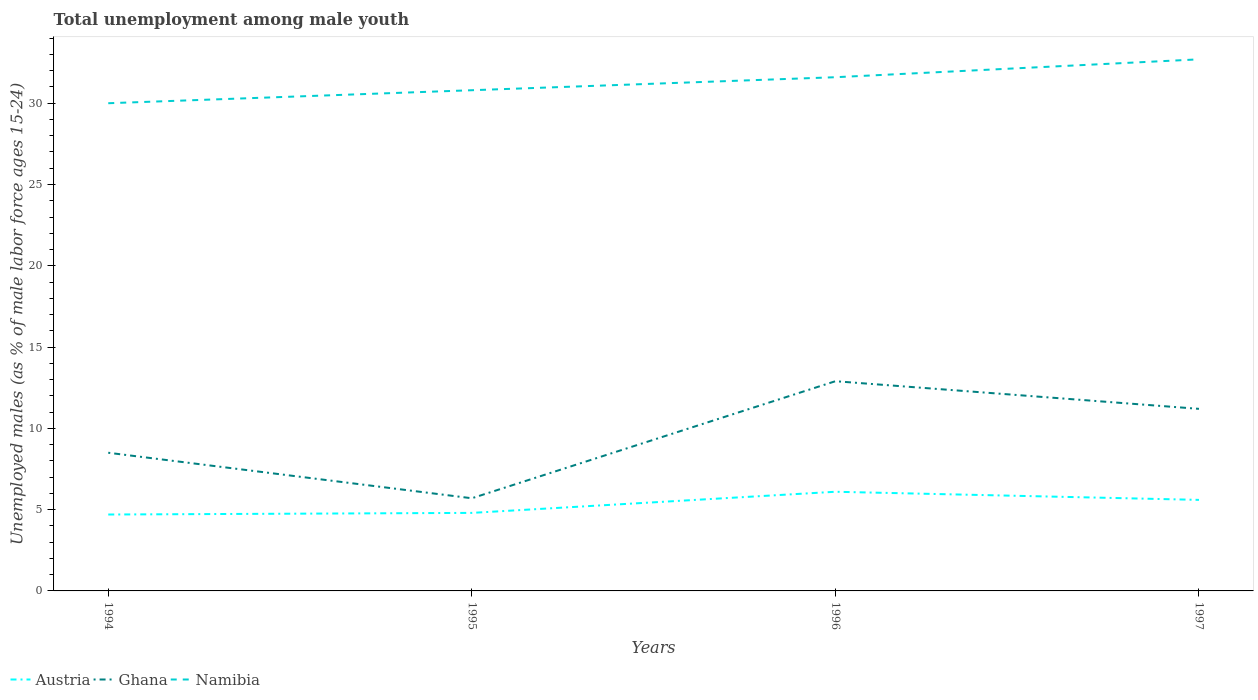Is the number of lines equal to the number of legend labels?
Ensure brevity in your answer.  Yes. Across all years, what is the maximum percentage of unemployed males in in Ghana?
Keep it short and to the point. 5.7. In which year was the percentage of unemployed males in in Ghana maximum?
Offer a terse response. 1995. What is the total percentage of unemployed males in in Ghana in the graph?
Give a very brief answer. 2.8. What is the difference between the highest and the second highest percentage of unemployed males in in Namibia?
Give a very brief answer. 2.7. Is the percentage of unemployed males in in Ghana strictly greater than the percentage of unemployed males in in Namibia over the years?
Keep it short and to the point. Yes. How many lines are there?
Your answer should be compact. 3. What is the difference between two consecutive major ticks on the Y-axis?
Ensure brevity in your answer.  5. How many legend labels are there?
Provide a succinct answer. 3. What is the title of the graph?
Your answer should be compact. Total unemployment among male youth. Does "Tanzania" appear as one of the legend labels in the graph?
Provide a succinct answer. No. What is the label or title of the X-axis?
Provide a short and direct response. Years. What is the label or title of the Y-axis?
Your response must be concise. Unemployed males (as % of male labor force ages 15-24). What is the Unemployed males (as % of male labor force ages 15-24) in Austria in 1994?
Provide a short and direct response. 4.7. What is the Unemployed males (as % of male labor force ages 15-24) in Ghana in 1994?
Provide a short and direct response. 8.5. What is the Unemployed males (as % of male labor force ages 15-24) of Namibia in 1994?
Provide a succinct answer. 30. What is the Unemployed males (as % of male labor force ages 15-24) of Austria in 1995?
Your answer should be compact. 4.8. What is the Unemployed males (as % of male labor force ages 15-24) of Ghana in 1995?
Offer a very short reply. 5.7. What is the Unemployed males (as % of male labor force ages 15-24) of Namibia in 1995?
Your answer should be very brief. 30.8. What is the Unemployed males (as % of male labor force ages 15-24) of Austria in 1996?
Your answer should be compact. 6.1. What is the Unemployed males (as % of male labor force ages 15-24) in Ghana in 1996?
Offer a terse response. 12.9. What is the Unemployed males (as % of male labor force ages 15-24) of Namibia in 1996?
Your response must be concise. 31.6. What is the Unemployed males (as % of male labor force ages 15-24) of Austria in 1997?
Offer a terse response. 5.6. What is the Unemployed males (as % of male labor force ages 15-24) in Ghana in 1997?
Provide a short and direct response. 11.2. What is the Unemployed males (as % of male labor force ages 15-24) in Namibia in 1997?
Provide a succinct answer. 32.7. Across all years, what is the maximum Unemployed males (as % of male labor force ages 15-24) in Austria?
Offer a terse response. 6.1. Across all years, what is the maximum Unemployed males (as % of male labor force ages 15-24) of Ghana?
Your answer should be very brief. 12.9. Across all years, what is the maximum Unemployed males (as % of male labor force ages 15-24) of Namibia?
Your answer should be very brief. 32.7. Across all years, what is the minimum Unemployed males (as % of male labor force ages 15-24) of Austria?
Your answer should be compact. 4.7. Across all years, what is the minimum Unemployed males (as % of male labor force ages 15-24) in Ghana?
Your answer should be compact. 5.7. Across all years, what is the minimum Unemployed males (as % of male labor force ages 15-24) of Namibia?
Give a very brief answer. 30. What is the total Unemployed males (as % of male labor force ages 15-24) in Austria in the graph?
Provide a succinct answer. 21.2. What is the total Unemployed males (as % of male labor force ages 15-24) of Ghana in the graph?
Keep it short and to the point. 38.3. What is the total Unemployed males (as % of male labor force ages 15-24) of Namibia in the graph?
Provide a short and direct response. 125.1. What is the difference between the Unemployed males (as % of male labor force ages 15-24) in Ghana in 1994 and that in 1995?
Provide a short and direct response. 2.8. What is the difference between the Unemployed males (as % of male labor force ages 15-24) of Namibia in 1994 and that in 1995?
Give a very brief answer. -0.8. What is the difference between the Unemployed males (as % of male labor force ages 15-24) in Austria in 1994 and that in 1996?
Make the answer very short. -1.4. What is the difference between the Unemployed males (as % of male labor force ages 15-24) in Ghana in 1994 and that in 1996?
Your answer should be very brief. -4.4. What is the difference between the Unemployed males (as % of male labor force ages 15-24) in Austria in 1994 and that in 1997?
Provide a short and direct response. -0.9. What is the difference between the Unemployed males (as % of male labor force ages 15-24) of Ghana in 1994 and that in 1997?
Your response must be concise. -2.7. What is the difference between the Unemployed males (as % of male labor force ages 15-24) of Namibia in 1995 and that in 1996?
Your answer should be very brief. -0.8. What is the difference between the Unemployed males (as % of male labor force ages 15-24) of Austria in 1995 and that in 1997?
Keep it short and to the point. -0.8. What is the difference between the Unemployed males (as % of male labor force ages 15-24) of Ghana in 1995 and that in 1997?
Ensure brevity in your answer.  -5.5. What is the difference between the Unemployed males (as % of male labor force ages 15-24) in Namibia in 1995 and that in 1997?
Give a very brief answer. -1.9. What is the difference between the Unemployed males (as % of male labor force ages 15-24) in Austria in 1996 and that in 1997?
Provide a succinct answer. 0.5. What is the difference between the Unemployed males (as % of male labor force ages 15-24) in Ghana in 1996 and that in 1997?
Your answer should be very brief. 1.7. What is the difference between the Unemployed males (as % of male labor force ages 15-24) in Namibia in 1996 and that in 1997?
Your answer should be compact. -1.1. What is the difference between the Unemployed males (as % of male labor force ages 15-24) in Austria in 1994 and the Unemployed males (as % of male labor force ages 15-24) in Namibia in 1995?
Provide a succinct answer. -26.1. What is the difference between the Unemployed males (as % of male labor force ages 15-24) in Ghana in 1994 and the Unemployed males (as % of male labor force ages 15-24) in Namibia in 1995?
Your answer should be very brief. -22.3. What is the difference between the Unemployed males (as % of male labor force ages 15-24) of Austria in 1994 and the Unemployed males (as % of male labor force ages 15-24) of Namibia in 1996?
Offer a very short reply. -26.9. What is the difference between the Unemployed males (as % of male labor force ages 15-24) in Ghana in 1994 and the Unemployed males (as % of male labor force ages 15-24) in Namibia in 1996?
Make the answer very short. -23.1. What is the difference between the Unemployed males (as % of male labor force ages 15-24) in Austria in 1994 and the Unemployed males (as % of male labor force ages 15-24) in Namibia in 1997?
Offer a very short reply. -28. What is the difference between the Unemployed males (as % of male labor force ages 15-24) in Ghana in 1994 and the Unemployed males (as % of male labor force ages 15-24) in Namibia in 1997?
Ensure brevity in your answer.  -24.2. What is the difference between the Unemployed males (as % of male labor force ages 15-24) of Austria in 1995 and the Unemployed males (as % of male labor force ages 15-24) of Namibia in 1996?
Offer a terse response. -26.8. What is the difference between the Unemployed males (as % of male labor force ages 15-24) of Ghana in 1995 and the Unemployed males (as % of male labor force ages 15-24) of Namibia in 1996?
Give a very brief answer. -25.9. What is the difference between the Unemployed males (as % of male labor force ages 15-24) of Austria in 1995 and the Unemployed males (as % of male labor force ages 15-24) of Ghana in 1997?
Give a very brief answer. -6.4. What is the difference between the Unemployed males (as % of male labor force ages 15-24) of Austria in 1995 and the Unemployed males (as % of male labor force ages 15-24) of Namibia in 1997?
Your response must be concise. -27.9. What is the difference between the Unemployed males (as % of male labor force ages 15-24) in Austria in 1996 and the Unemployed males (as % of male labor force ages 15-24) in Ghana in 1997?
Make the answer very short. -5.1. What is the difference between the Unemployed males (as % of male labor force ages 15-24) in Austria in 1996 and the Unemployed males (as % of male labor force ages 15-24) in Namibia in 1997?
Offer a terse response. -26.6. What is the difference between the Unemployed males (as % of male labor force ages 15-24) of Ghana in 1996 and the Unemployed males (as % of male labor force ages 15-24) of Namibia in 1997?
Your response must be concise. -19.8. What is the average Unemployed males (as % of male labor force ages 15-24) in Ghana per year?
Provide a short and direct response. 9.57. What is the average Unemployed males (as % of male labor force ages 15-24) of Namibia per year?
Keep it short and to the point. 31.27. In the year 1994, what is the difference between the Unemployed males (as % of male labor force ages 15-24) in Austria and Unemployed males (as % of male labor force ages 15-24) in Namibia?
Make the answer very short. -25.3. In the year 1994, what is the difference between the Unemployed males (as % of male labor force ages 15-24) of Ghana and Unemployed males (as % of male labor force ages 15-24) of Namibia?
Offer a terse response. -21.5. In the year 1995, what is the difference between the Unemployed males (as % of male labor force ages 15-24) of Ghana and Unemployed males (as % of male labor force ages 15-24) of Namibia?
Give a very brief answer. -25.1. In the year 1996, what is the difference between the Unemployed males (as % of male labor force ages 15-24) of Austria and Unemployed males (as % of male labor force ages 15-24) of Namibia?
Your response must be concise. -25.5. In the year 1996, what is the difference between the Unemployed males (as % of male labor force ages 15-24) of Ghana and Unemployed males (as % of male labor force ages 15-24) of Namibia?
Offer a very short reply. -18.7. In the year 1997, what is the difference between the Unemployed males (as % of male labor force ages 15-24) of Austria and Unemployed males (as % of male labor force ages 15-24) of Namibia?
Ensure brevity in your answer.  -27.1. In the year 1997, what is the difference between the Unemployed males (as % of male labor force ages 15-24) in Ghana and Unemployed males (as % of male labor force ages 15-24) in Namibia?
Offer a very short reply. -21.5. What is the ratio of the Unemployed males (as % of male labor force ages 15-24) in Austria in 1994 to that in 1995?
Ensure brevity in your answer.  0.98. What is the ratio of the Unemployed males (as % of male labor force ages 15-24) of Ghana in 1994 to that in 1995?
Your answer should be compact. 1.49. What is the ratio of the Unemployed males (as % of male labor force ages 15-24) of Namibia in 1994 to that in 1995?
Provide a short and direct response. 0.97. What is the ratio of the Unemployed males (as % of male labor force ages 15-24) of Austria in 1994 to that in 1996?
Provide a succinct answer. 0.77. What is the ratio of the Unemployed males (as % of male labor force ages 15-24) of Ghana in 1994 to that in 1996?
Provide a short and direct response. 0.66. What is the ratio of the Unemployed males (as % of male labor force ages 15-24) in Namibia in 1994 to that in 1996?
Your answer should be very brief. 0.95. What is the ratio of the Unemployed males (as % of male labor force ages 15-24) of Austria in 1994 to that in 1997?
Make the answer very short. 0.84. What is the ratio of the Unemployed males (as % of male labor force ages 15-24) of Ghana in 1994 to that in 1997?
Provide a short and direct response. 0.76. What is the ratio of the Unemployed males (as % of male labor force ages 15-24) in Namibia in 1994 to that in 1997?
Offer a very short reply. 0.92. What is the ratio of the Unemployed males (as % of male labor force ages 15-24) of Austria in 1995 to that in 1996?
Provide a succinct answer. 0.79. What is the ratio of the Unemployed males (as % of male labor force ages 15-24) of Ghana in 1995 to that in 1996?
Your answer should be compact. 0.44. What is the ratio of the Unemployed males (as % of male labor force ages 15-24) of Namibia in 1995 to that in 1996?
Provide a succinct answer. 0.97. What is the ratio of the Unemployed males (as % of male labor force ages 15-24) of Ghana in 1995 to that in 1997?
Your answer should be compact. 0.51. What is the ratio of the Unemployed males (as % of male labor force ages 15-24) of Namibia in 1995 to that in 1997?
Ensure brevity in your answer.  0.94. What is the ratio of the Unemployed males (as % of male labor force ages 15-24) in Austria in 1996 to that in 1997?
Provide a short and direct response. 1.09. What is the ratio of the Unemployed males (as % of male labor force ages 15-24) of Ghana in 1996 to that in 1997?
Make the answer very short. 1.15. What is the ratio of the Unemployed males (as % of male labor force ages 15-24) in Namibia in 1996 to that in 1997?
Ensure brevity in your answer.  0.97. What is the difference between the highest and the second highest Unemployed males (as % of male labor force ages 15-24) in Namibia?
Your answer should be very brief. 1.1. What is the difference between the highest and the lowest Unemployed males (as % of male labor force ages 15-24) in Ghana?
Keep it short and to the point. 7.2. 